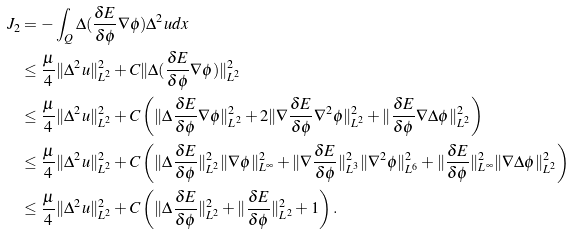<formula> <loc_0><loc_0><loc_500><loc_500>J _ { 2 } & = - \int _ { Q } \Delta ( \frac { \delta E } { \delta \phi } \nabla \phi ) \Delta ^ { 2 } u d x \\ & \leq \frac { \mu } { 4 } \| \Delta ^ { 2 } u \| _ { L ^ { 2 } } ^ { 2 } + C \| \Delta ( \frac { \delta E } { \delta \phi } \nabla \phi ) \| _ { L ^ { 2 } } ^ { 2 } \\ & \leq \frac { \mu } { 4 } \| \Delta ^ { 2 } u \| _ { L ^ { 2 } } ^ { 2 } + C \left ( \| \Delta \frac { \delta E } { \delta \phi } \nabla \phi \| _ { L ^ { 2 } } ^ { 2 } + 2 \| \nabla \frac { \delta E } { \delta \phi } \nabla ^ { 2 } \phi \| _ { L ^ { 2 } } ^ { 2 } + \| \frac { \delta E } { \delta \phi } \nabla \Delta \phi \| _ { L ^ { 2 } } ^ { 2 } \right ) \\ & \leq \frac { \mu } { 4 } \| \Delta ^ { 2 } u \| _ { L ^ { 2 } } ^ { 2 } + C \left ( \| \Delta \frac { \delta E } { \delta \phi } \| _ { L ^ { 2 } } ^ { 2 } \| \nabla \phi \| _ { L ^ { \infty } } ^ { 2 } + \| \nabla \frac { \delta E } { \delta \phi } \| _ { L ^ { 3 } } ^ { 2 } \| \nabla ^ { 2 } \phi \| _ { L ^ { 6 } } ^ { 2 } + \| \frac { \delta E } { \delta \phi } \| _ { L ^ { \infty } } ^ { 2 } \| \nabla \Delta \phi \| _ { L ^ { 2 } } ^ { 2 } \right ) \\ & \leq \frac { \mu } { 4 } \| \Delta ^ { 2 } u \| _ { L ^ { 2 } } ^ { 2 } + C \left ( \| \Delta \frac { \delta E } { \delta \phi } \| _ { L ^ { 2 } } ^ { 2 } + \| \frac { \delta E } { \delta \phi } \| _ { L ^ { 2 } } ^ { 2 } + 1 \right ) .</formula> 